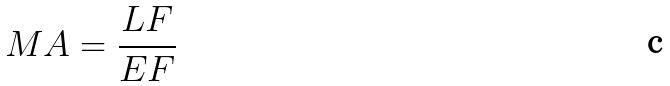Convert formula to latex. <formula><loc_0><loc_0><loc_500><loc_500>M A = \frac { L F } { E F }</formula> 